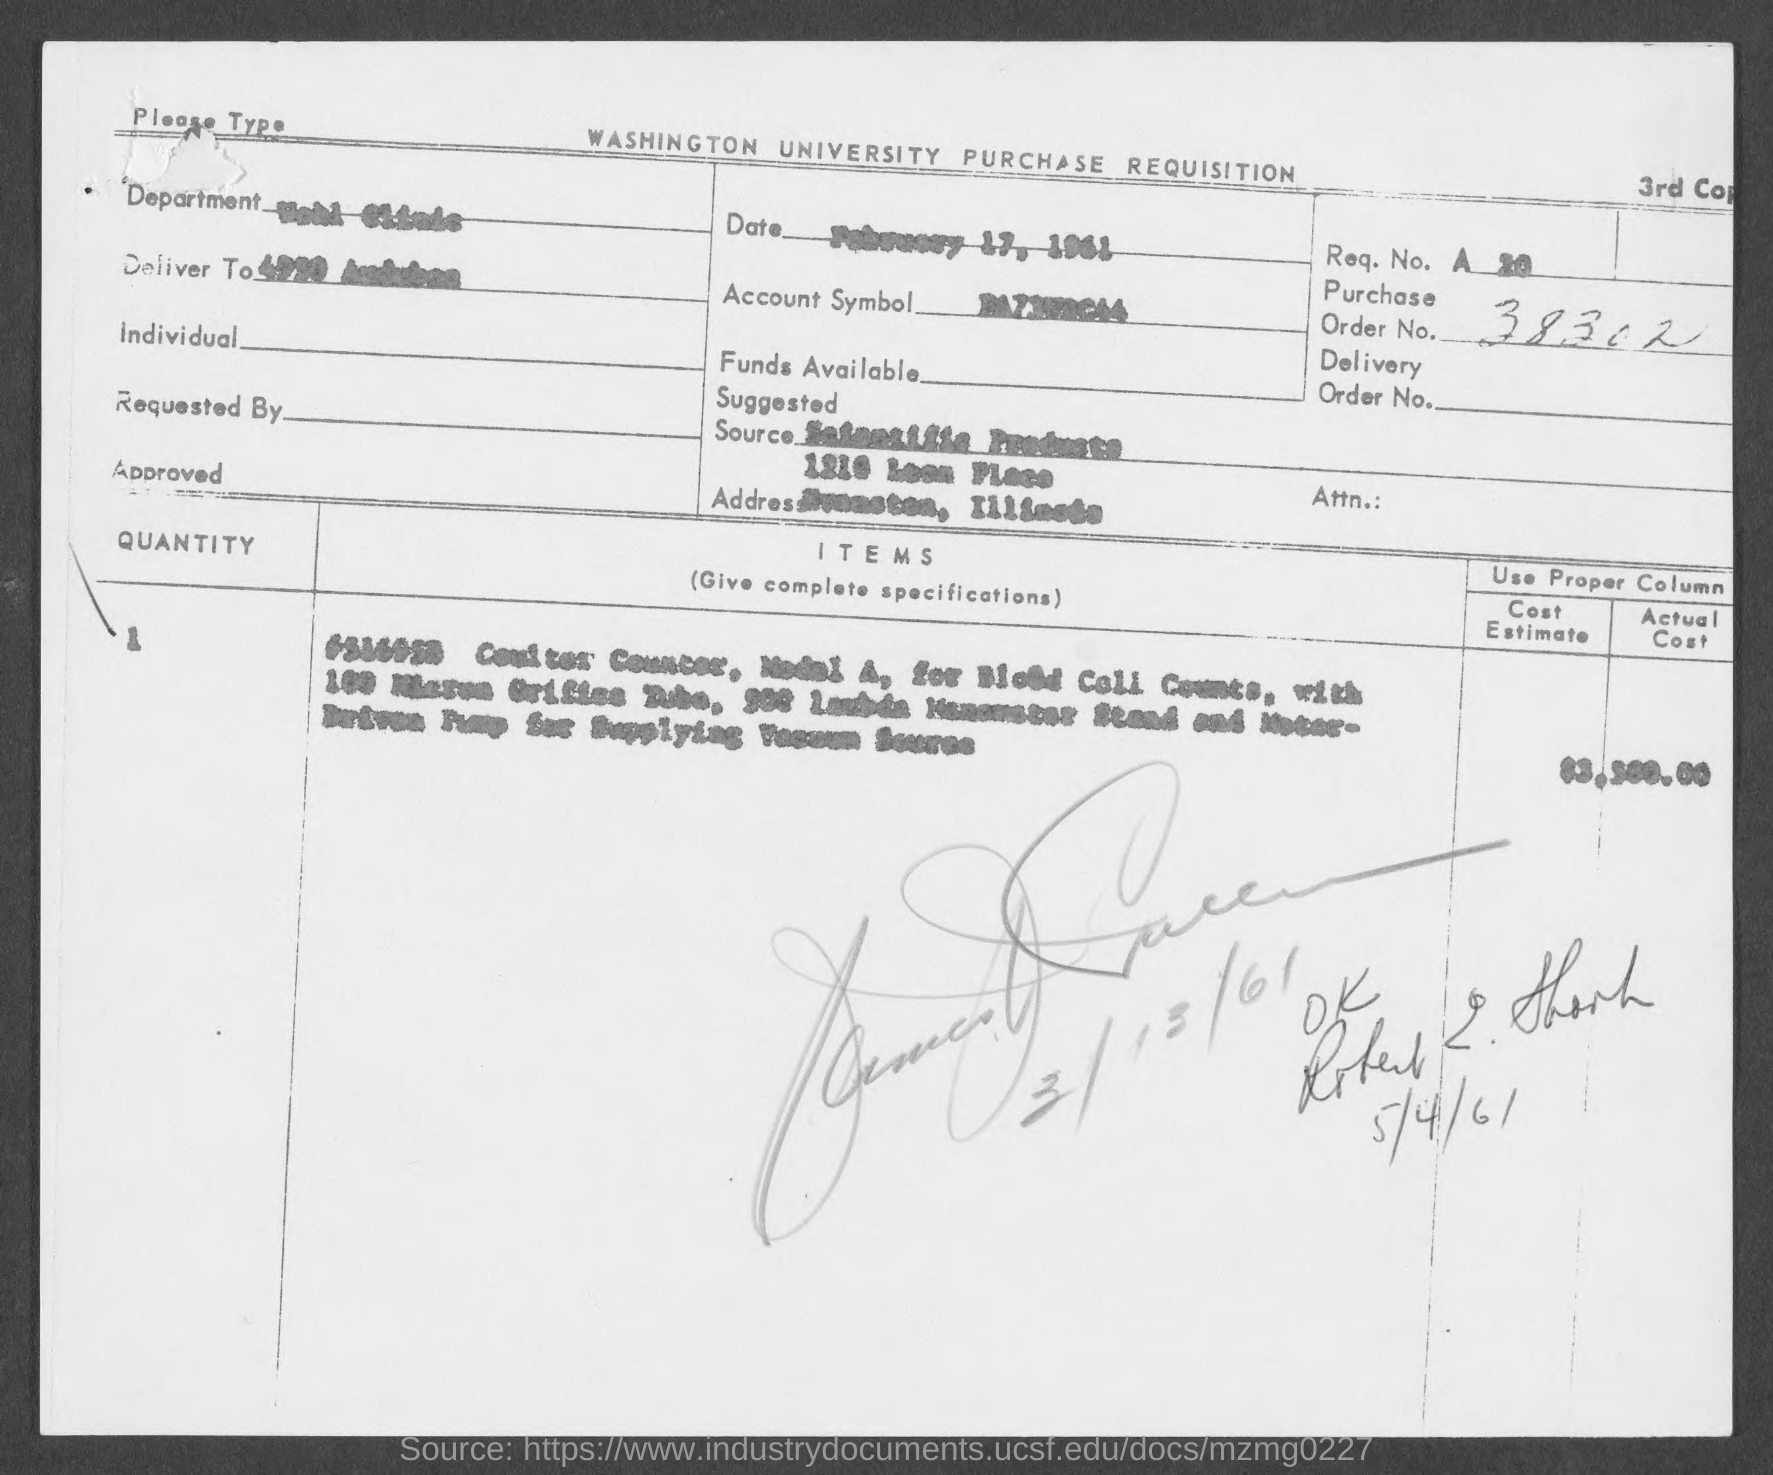Draw attention to some important aspects in this diagram. The order number is 38302...," the customer declared. The date is February 17, 1961. 